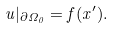<formula> <loc_0><loc_0><loc_500><loc_500>u | _ { \partial \Omega _ { 0 } } = f ( x ^ { \prime } ) .</formula> 